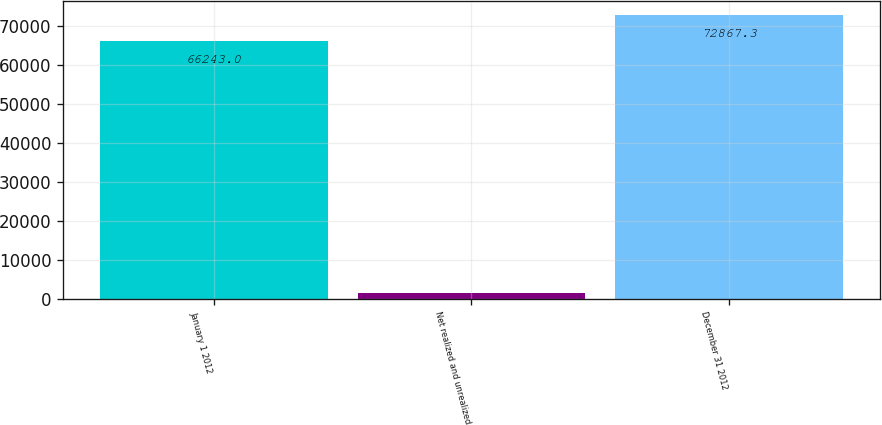Convert chart. <chart><loc_0><loc_0><loc_500><loc_500><bar_chart><fcel>January 1 2012<fcel>Net realized and unrealized<fcel>December 31 2012<nl><fcel>66243<fcel>1519<fcel>72867.3<nl></chart> 